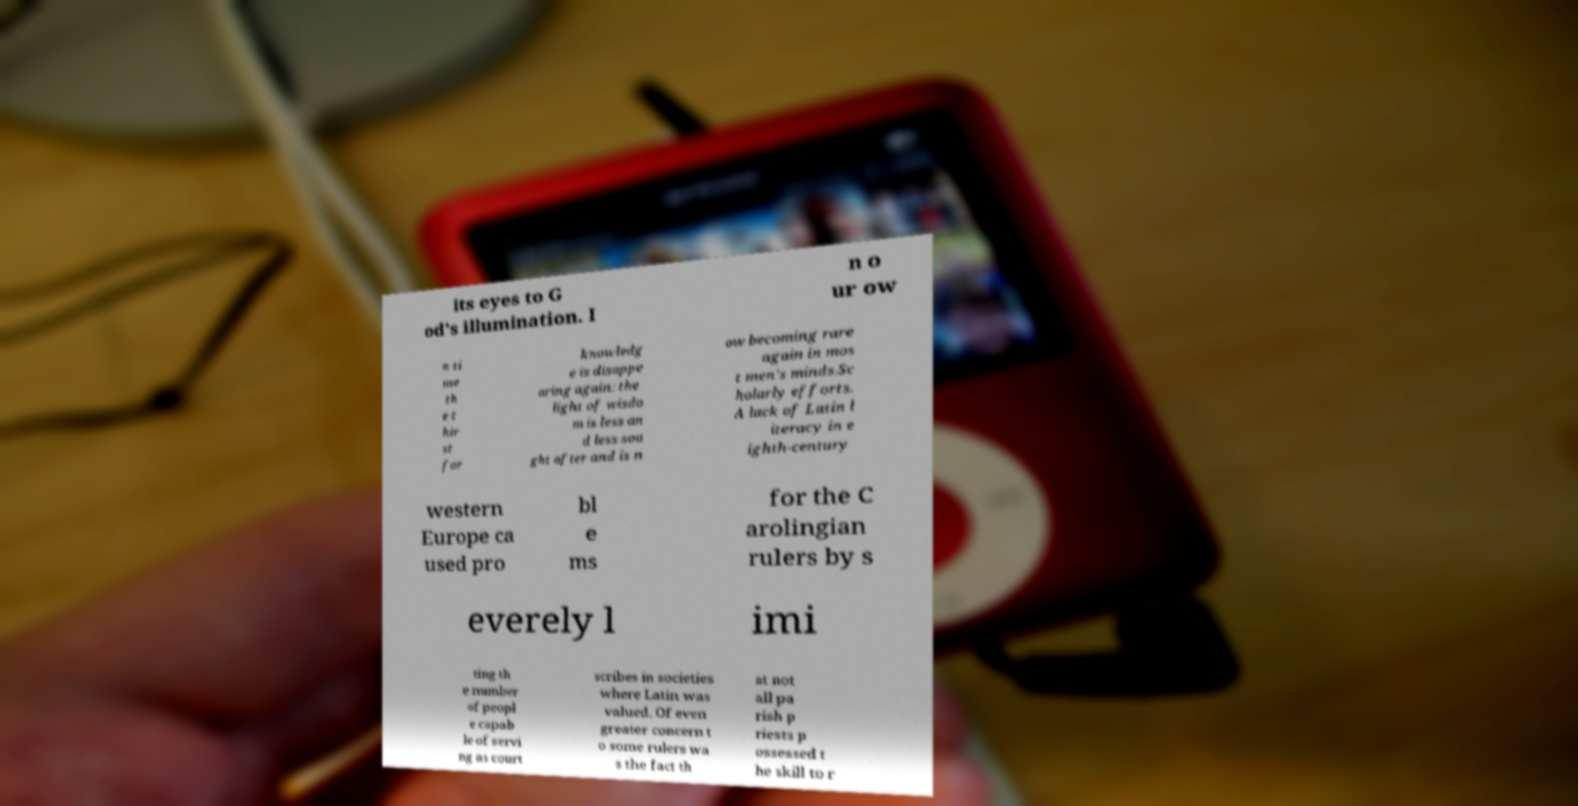Please read and relay the text visible in this image. What does it say? its eyes to G od's illumination. I n o ur ow n ti me th e t hir st for knowledg e is disappe aring again: the light of wisdo m is less an d less sou ght after and is n ow becoming rare again in mos t men's minds.Sc holarly efforts. A lack of Latin l iteracy in e ighth-century western Europe ca used pro bl e ms for the C arolingian rulers by s everely l imi ting th e number of peopl e capab le of servi ng as court scribes in societies where Latin was valued. Of even greater concern t o some rulers wa s the fact th at not all pa rish p riests p ossessed t he skill to r 